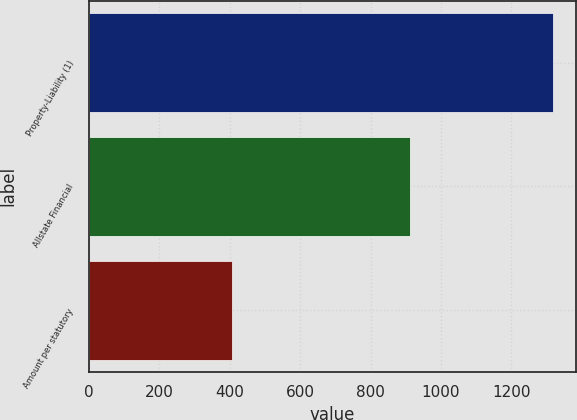Convert chart to OTSL. <chart><loc_0><loc_0><loc_500><loc_500><bar_chart><fcel>Property-Liability (1)<fcel>Allstate Financial<fcel>Amount per statutory<nl><fcel>1318<fcel>911<fcel>407<nl></chart> 